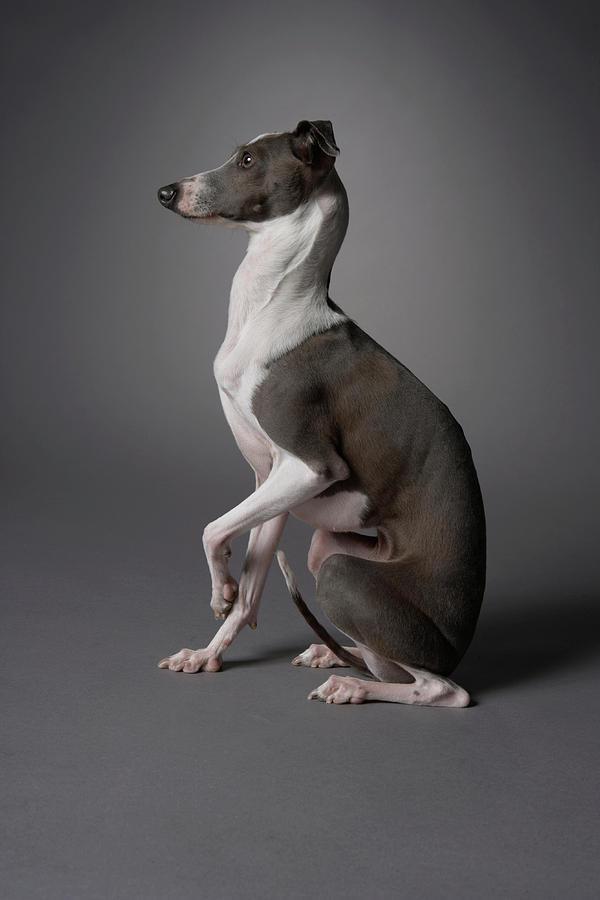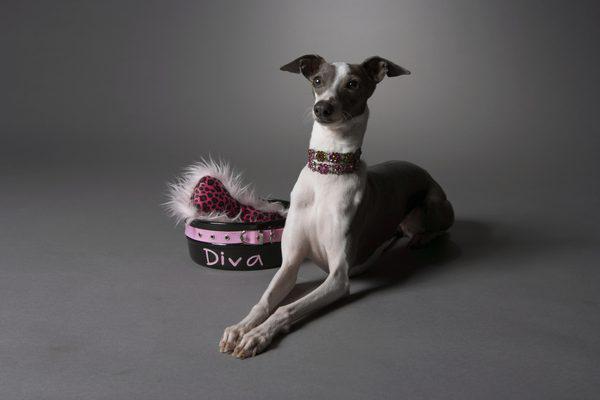The first image is the image on the left, the second image is the image on the right. For the images shown, is this caption "There are more dogs in the right image than in the left." true? Answer yes or no. No. The first image is the image on the left, the second image is the image on the right. For the images displayed, is the sentence "All dogs are wearing fancy, colorful collars." factually correct? Answer yes or no. No. 